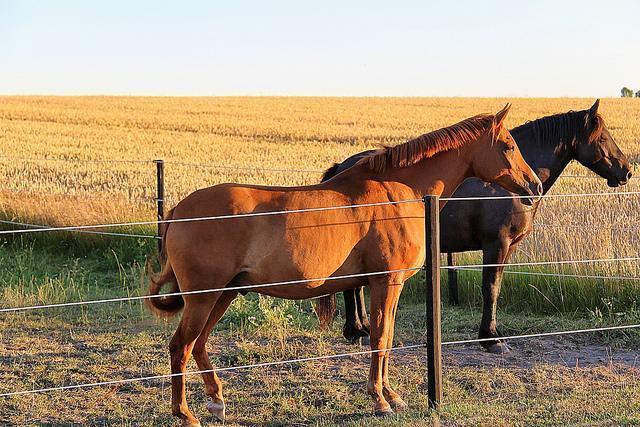How many animals are here?
Give a very brief answer. 2. How many horses are there?
Give a very brief answer. 2. 